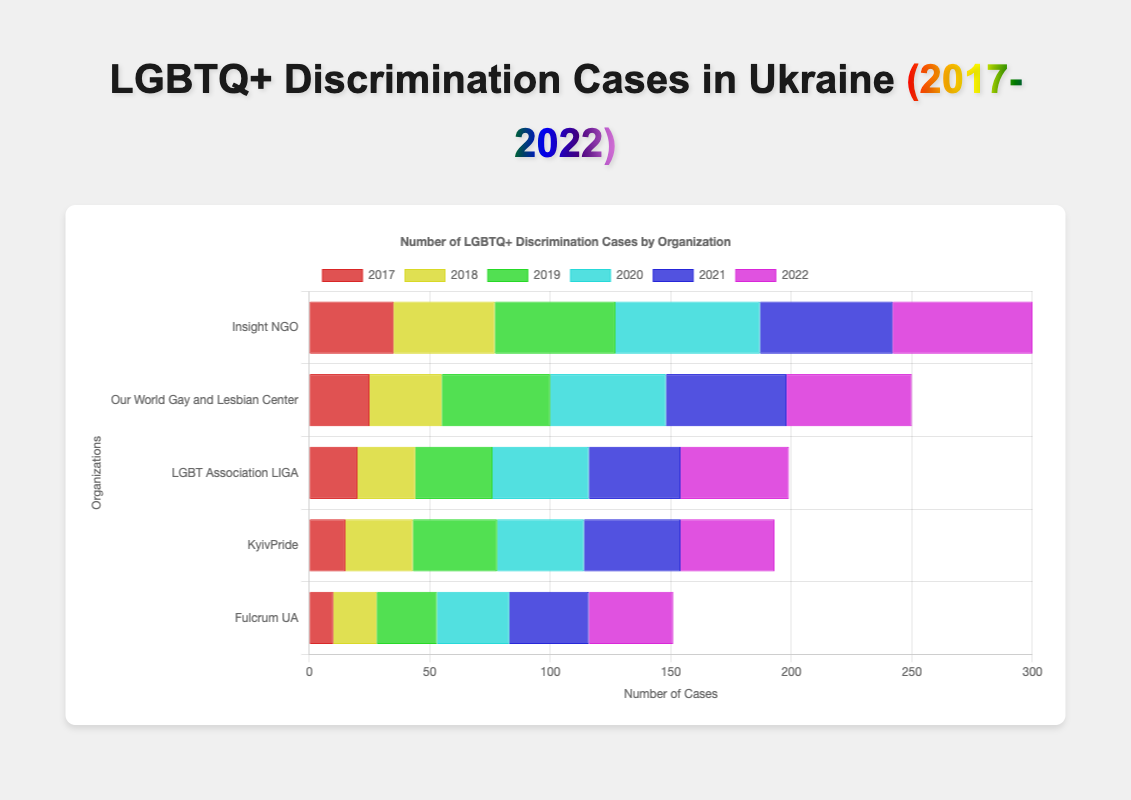1. Which organization had the highest number of cases in 2022, and what was the total number of cases reported by all organizations that year? The organization with the highest number of cases in 2022 can be determined by comparing the bar lengths for each organization in 2022. Adding up the numbers: Insight NGO (58), Our World Gay and Lesbian Center (52), LGBT Association LIGA (45), KyivPride (39), Fulcrum UA (35), the total is 58 + 52 + 45 + 39 + 35 = 229.
Answer: Insight NGO, 229 2. What is the difference in the total number of discrimination cases reported by Insight NGO and Fulcrum UA over these six years? Sum of Insight NGO cases: 35 + 42 + 50 + 60 + 55 + 58 = 300, and Fulcrum UA cases: 10 + 18 + 25 + 30 + 33 + 35 = 151. The difference is 300 - 151 = 149.
Answer: 149 3. Which organization reported fewer cases in 2017: KyivPride or Fulcrum UA? Compare the bar lengths for KyivPride (15) and Fulcrum UA (10) in 2017. Fulcrum UA reported fewer cases.
Answer: Fulcrum UA 4. In which year did LGBT Association LIGA report the highest number of cases? Look at the bar lengths for LGBT Association LIGA over the years. The longest bar corresponds to 2022 with 45 cases.
Answer: 2022 5. In 2020, which two organizations had the most similar number of cases reported? Compare the bar lengths in 2020 for all organizations. KyivPride (36) and Our World Gay and Lesbian Center (48) had the closest bar lengths, with a difference of 12 cases being the smallest discrepancy.
Answer: KyivPride and LGBT Association LIGA 6. Which year had the most uniform distribution of cases among the organizations? Visually compare the bar heights across each year. The year where bars are most similar in height is 2021.
Answer: 2021 7. Which organization's cases bar is the tallest in 2020? Visually, the tallest bar in 2020 is for Insight NGO with 60 cases.
Answer: Insight NGO 8. Are there any years when two organizations report the exact same number of cases? View the bars for each year to identify matching lengths. There are no instances where two organizations have bars of exactly matching height in any year.
Answer: No 